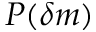<formula> <loc_0><loc_0><loc_500><loc_500>P ( \delta m )</formula> 